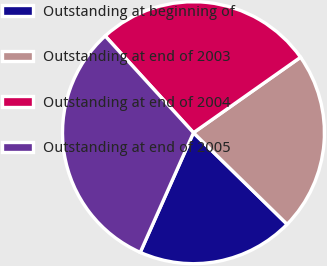Convert chart to OTSL. <chart><loc_0><loc_0><loc_500><loc_500><pie_chart><fcel>Outstanding at beginning of<fcel>Outstanding at end of 2003<fcel>Outstanding at end of 2004<fcel>Outstanding at end of 2005<nl><fcel>19.34%<fcel>22.09%<fcel>27.0%<fcel>31.56%<nl></chart> 